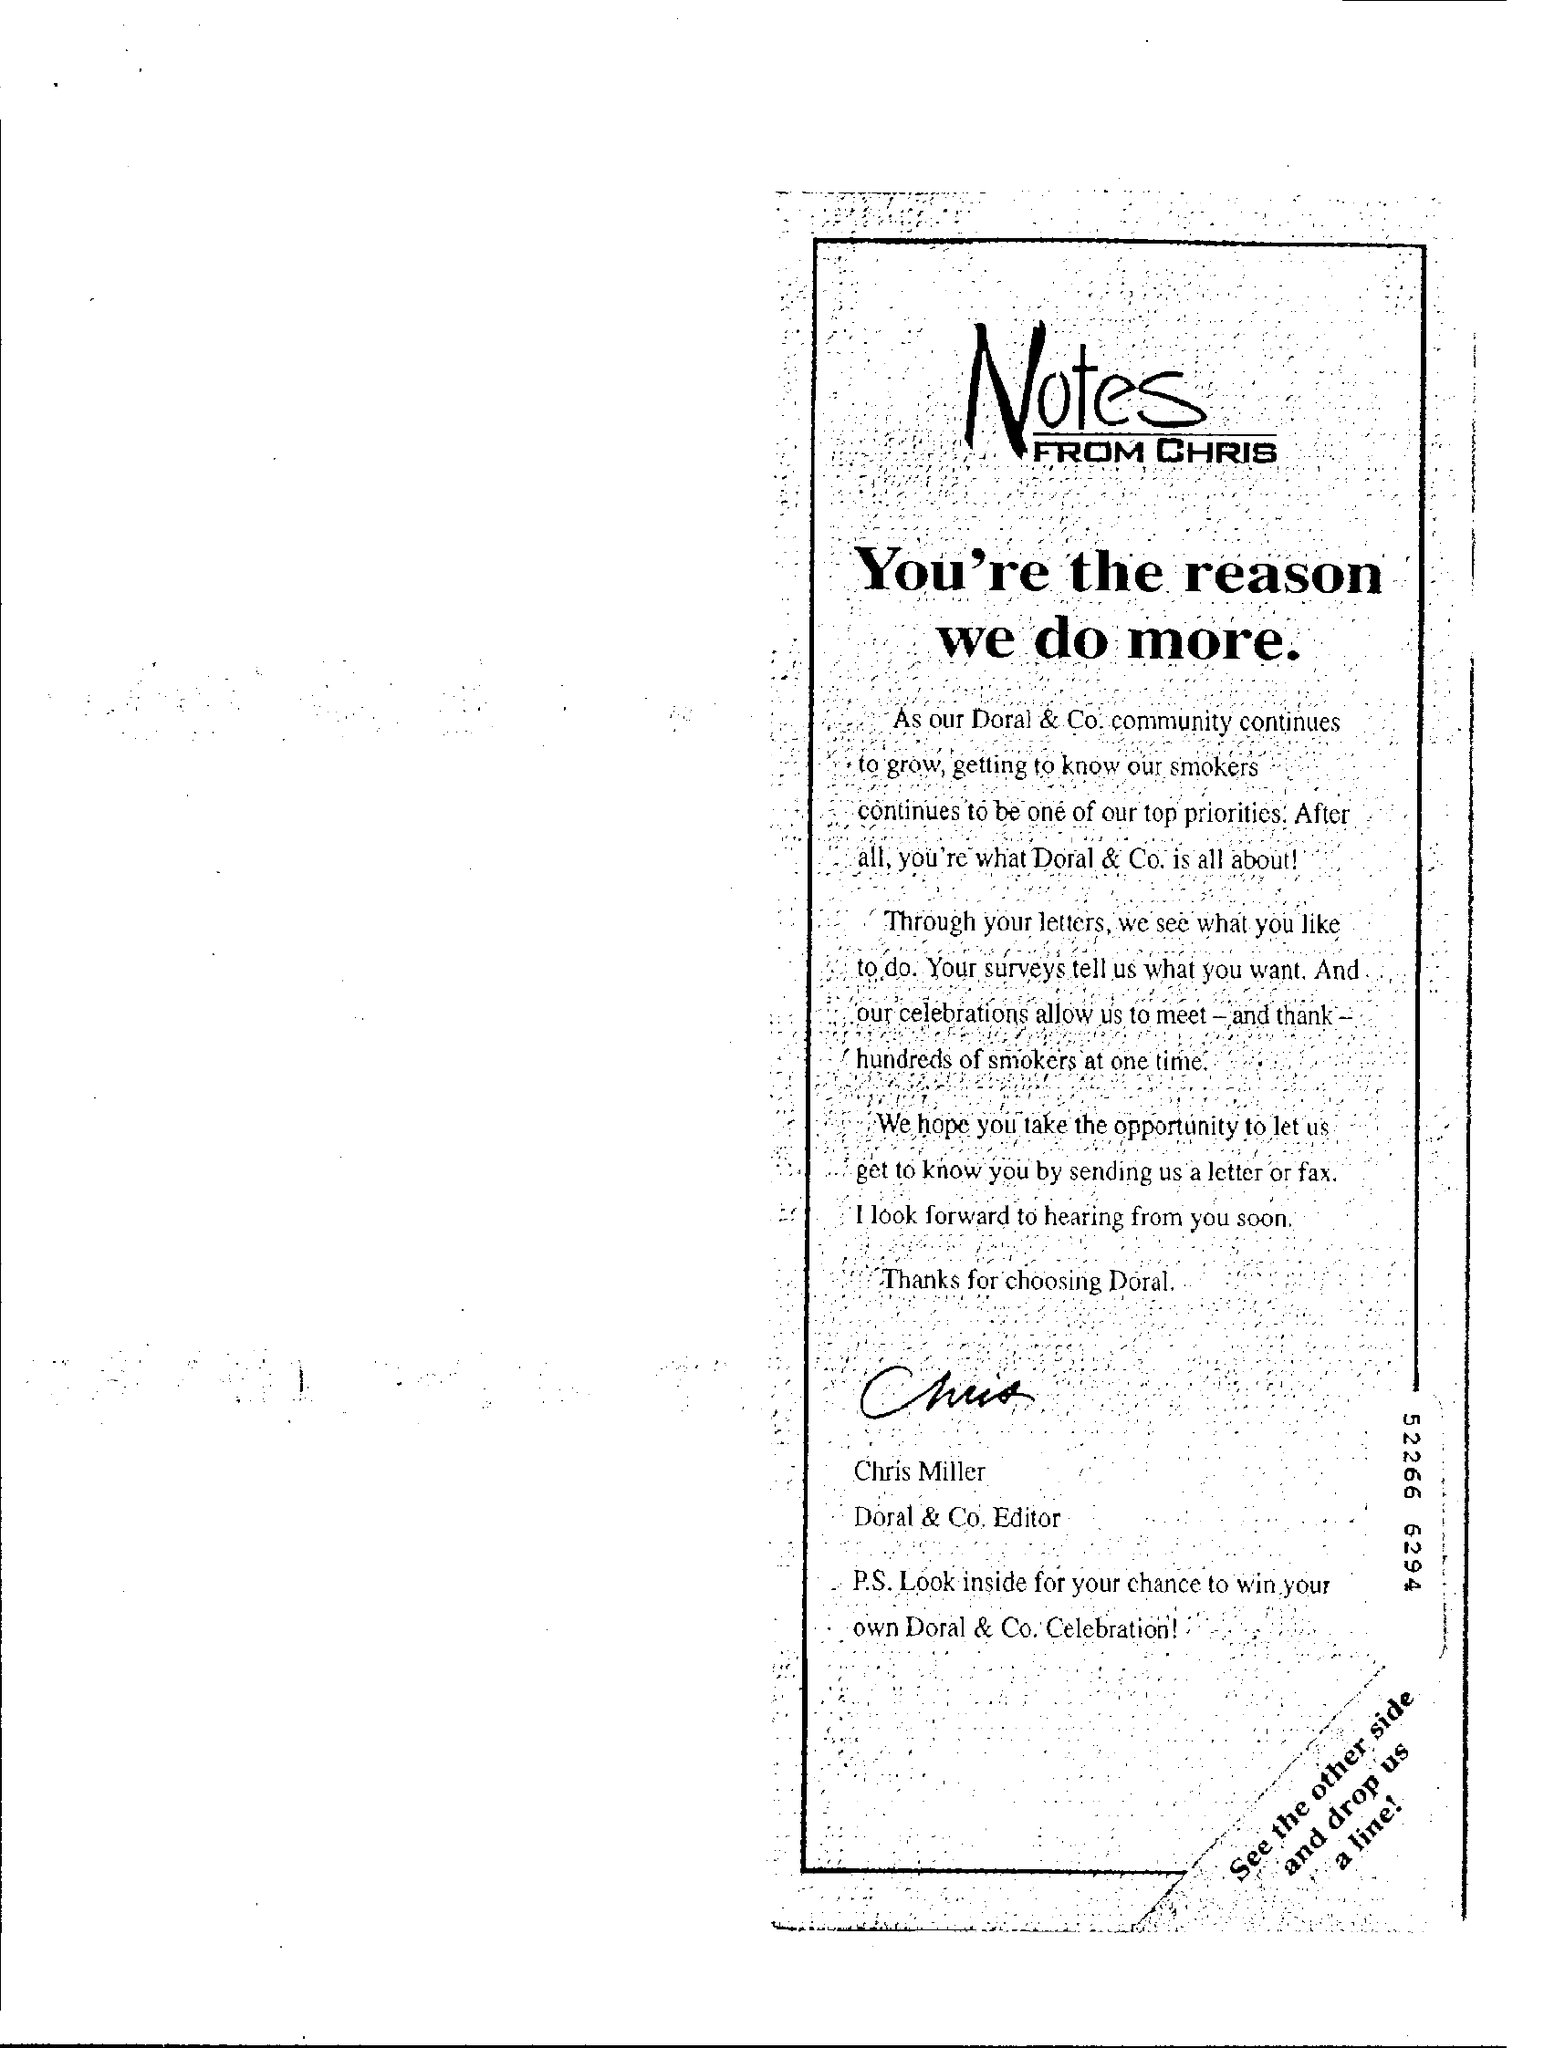What is the Title of the document?
Offer a very short reply. Notes from Chris. Who is the Doral & Co. Editor?
Your answer should be compact. Chris Miller. 